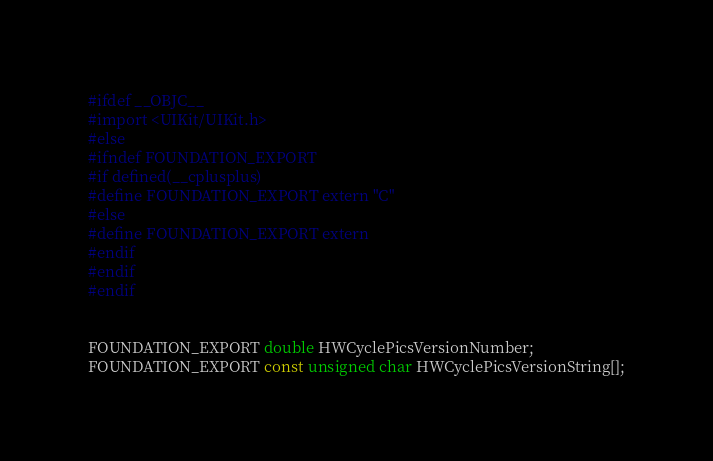<code> <loc_0><loc_0><loc_500><loc_500><_C_>#ifdef __OBJC__
#import <UIKit/UIKit.h>
#else
#ifndef FOUNDATION_EXPORT
#if defined(__cplusplus)
#define FOUNDATION_EXPORT extern "C"
#else
#define FOUNDATION_EXPORT extern
#endif
#endif
#endif


FOUNDATION_EXPORT double HWCyclePicsVersionNumber;
FOUNDATION_EXPORT const unsigned char HWCyclePicsVersionString[];

</code> 